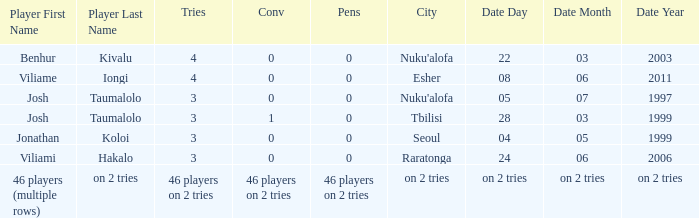What player played on 04/05/1999 with a conv of 0? Jonathan Koloi. 